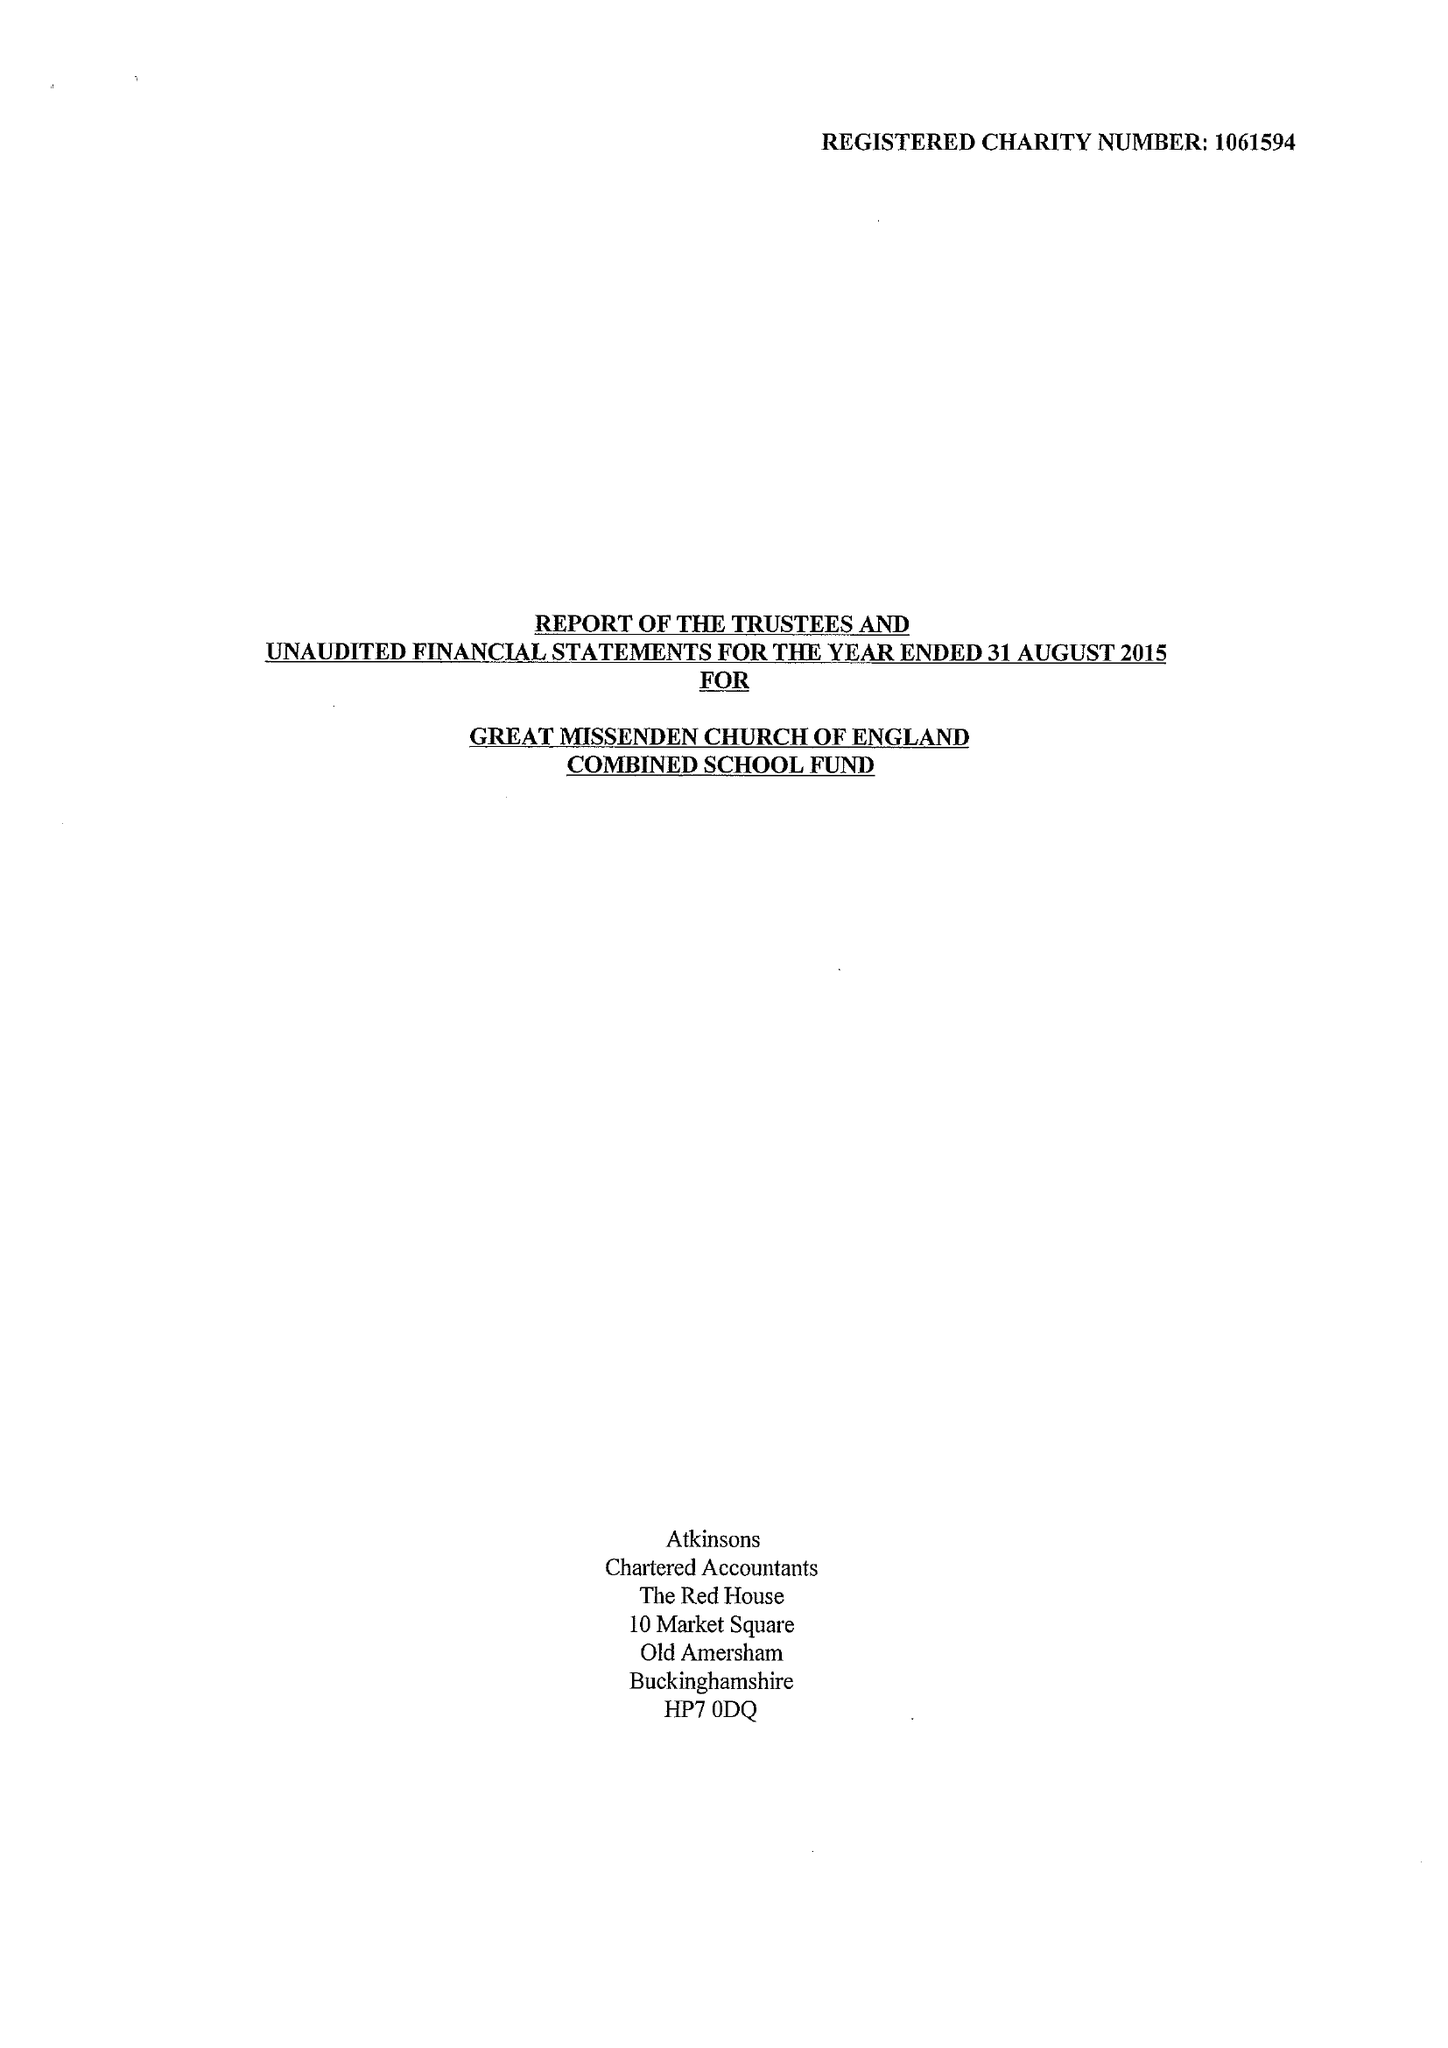What is the value for the income_annually_in_british_pounds?
Answer the question using a single word or phrase. 251206.00 